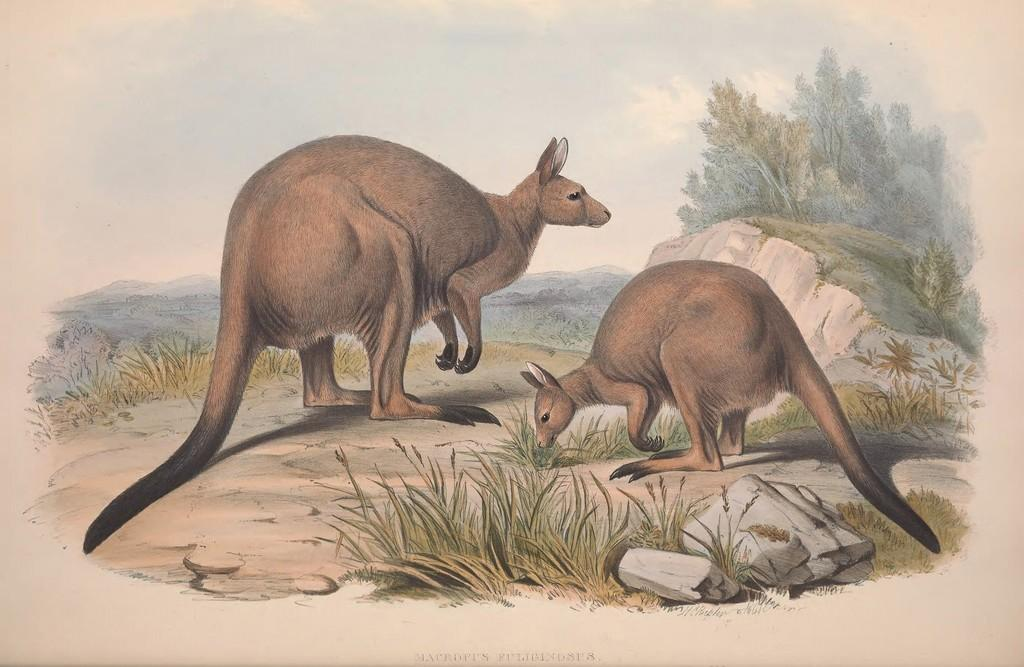What is located in the center of the image? There are animals in the center of the image. What type of terrain is visible at the bottom of the image? There is grass and rocks at the bottom of the image. What can be seen in the background of the image? There are trees, hills, and the sky visible in the background of the image. What type of wind can be seen blowing through the army in the image? There is no army or wind present in the image. What type of basin is visible in the image? There is no basin present in the image. 